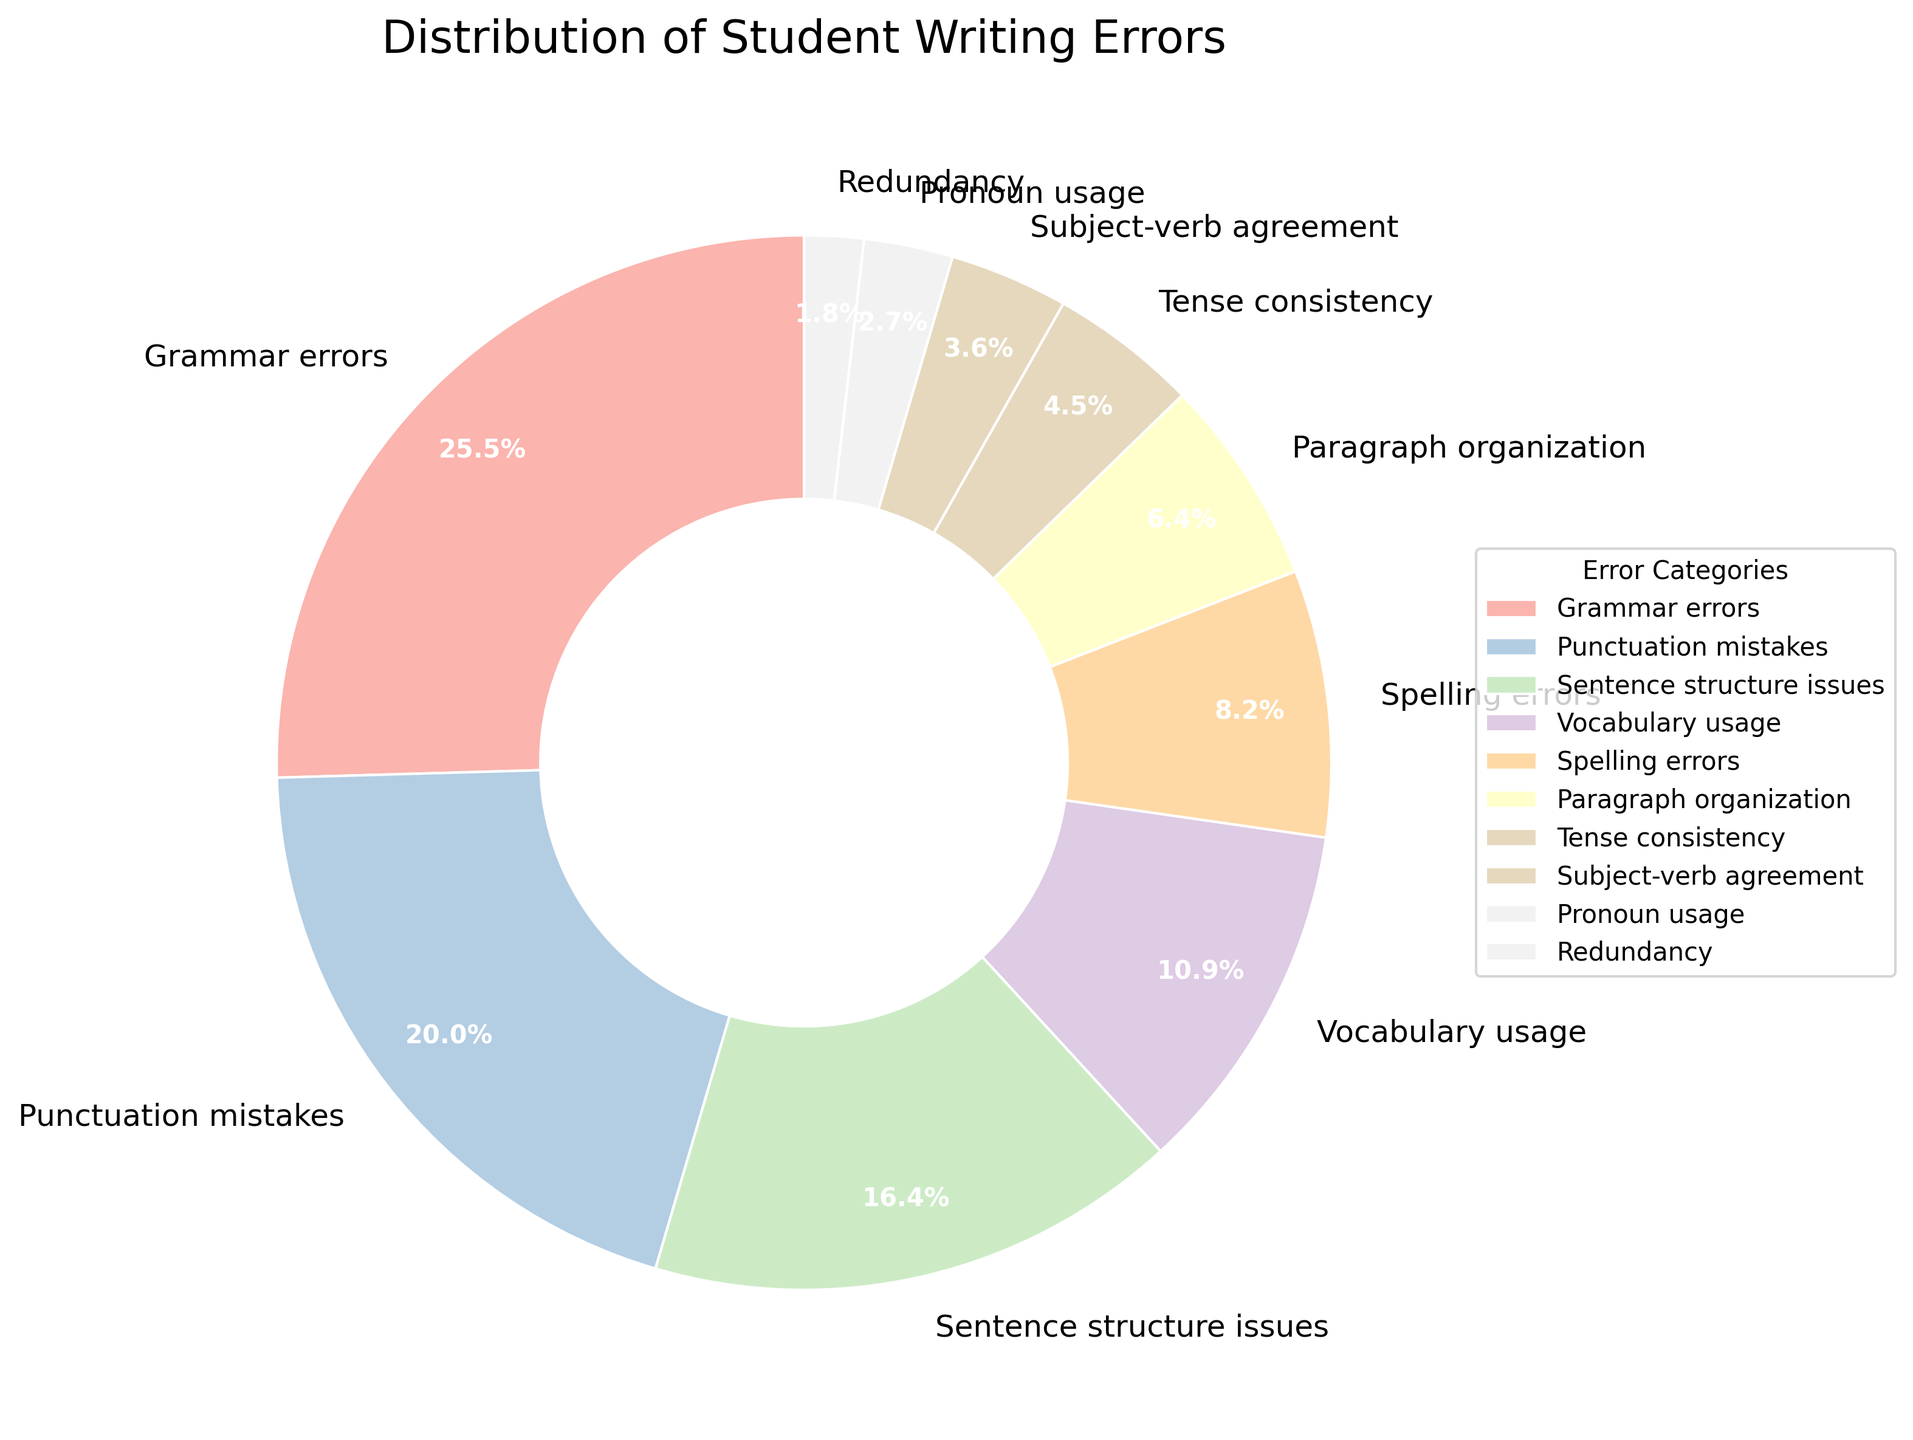Which error category has the highest percentage of writing errors? Look at the pie chart to identify the segment with the largest value. The category with the highest percentage is "Grammar errors" at 28%.
Answer: Grammar errors What is the total percentage of errors related to grammar, punctuation, and sentence structure? Sum the percentages of "Grammar errors" (28%), "Punctuation mistakes" (22%), and "Sentence structure issues" (18%). The total is 28 + 22 + 18 = 68%.
Answer: 68% How does the percentage of vocabulary usage errors compare to spelling errors? Look at the pie chart to find the percentages of "Vocabulary usage" (12%) and "Spelling errors" (9%). Vocabulary usage errors (12%) are greater than spelling errors (9%).
Answer: Vocabulary usage errors are greater What is the combined percentage of errors with less than 5%? Add the percentages of "Tense consistency" (5%), "Subject-verb agreement" (4%), "Pronoun usage" (3%), and "Redundancy" (2%). The total is 5 + 4 + 3 + 2 = 14%.
Answer: 14% What percentage of errors are related to paragraph organization and tense consistency combined? Sum the percentages of "Paragraph organization" (7%) and "Tense consistency" (5%). The combined percentage is 7 + 5 = 12%.
Answer: 12% Are there more errors in spelling or in subject-verb agreement? Compare the percentages of "Spelling errors" (9%) and "Subject-verb agreement" (4%). Spelling errors (9%) are more frequent than subject-verb agreement errors (4%).
Answer: Spelling errors are more frequent Which error category constitutes exactly 18% of the total errors? Refer to the pie chart to identify the segment labeled with 18%. The category is "Sentence structure issues".
Answer: Sentence structure issues Which two lowest categories together make up 5% of the total errors? Find the segments with the lowest percentages: "Redundancy" (2%) and "Pronoun usage" (3%). Their combined percentage is 2% + 3% = 5%.
Answer: Redundancy and Pronoun usage What is the percentage difference between grammar errors and punctuation mistakes? Subtract the percentage of "Punctuation mistakes" (22%) from "Grammar errors" (28%). The difference is 28 - 22 = 6%.
Answer: 6% 